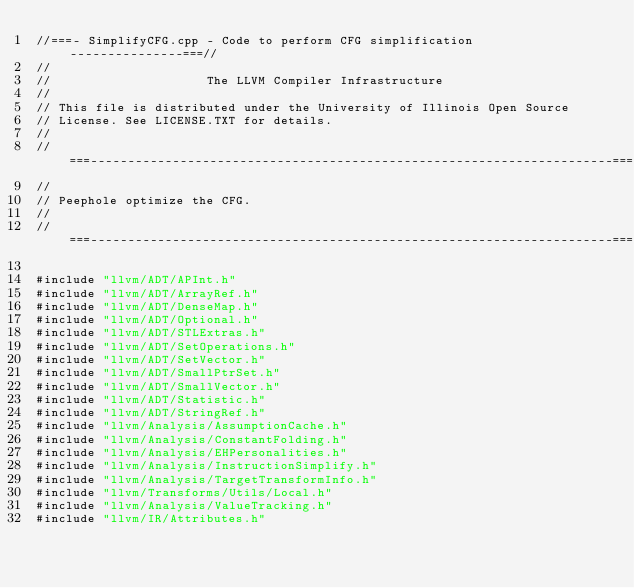<code> <loc_0><loc_0><loc_500><loc_500><_C++_>//===- SimplifyCFG.cpp - Code to perform CFG simplification ---------------===//
//
//                     The LLVM Compiler Infrastructure
//
// This file is distributed under the University of Illinois Open Source
// License. See LICENSE.TXT for details.
//
//===----------------------------------------------------------------------===//
//
// Peephole optimize the CFG.
//
//===----------------------------------------------------------------------===//

#include "llvm/ADT/APInt.h"
#include "llvm/ADT/ArrayRef.h"
#include "llvm/ADT/DenseMap.h"
#include "llvm/ADT/Optional.h"
#include "llvm/ADT/STLExtras.h"
#include "llvm/ADT/SetOperations.h"
#include "llvm/ADT/SetVector.h"
#include "llvm/ADT/SmallPtrSet.h"
#include "llvm/ADT/SmallVector.h"
#include "llvm/ADT/Statistic.h"
#include "llvm/ADT/StringRef.h"
#include "llvm/Analysis/AssumptionCache.h"
#include "llvm/Analysis/ConstantFolding.h"
#include "llvm/Analysis/EHPersonalities.h"
#include "llvm/Analysis/InstructionSimplify.h"
#include "llvm/Analysis/TargetTransformInfo.h"
#include "llvm/Transforms/Utils/Local.h"
#include "llvm/Analysis/ValueTracking.h"
#include "llvm/IR/Attributes.h"</code> 